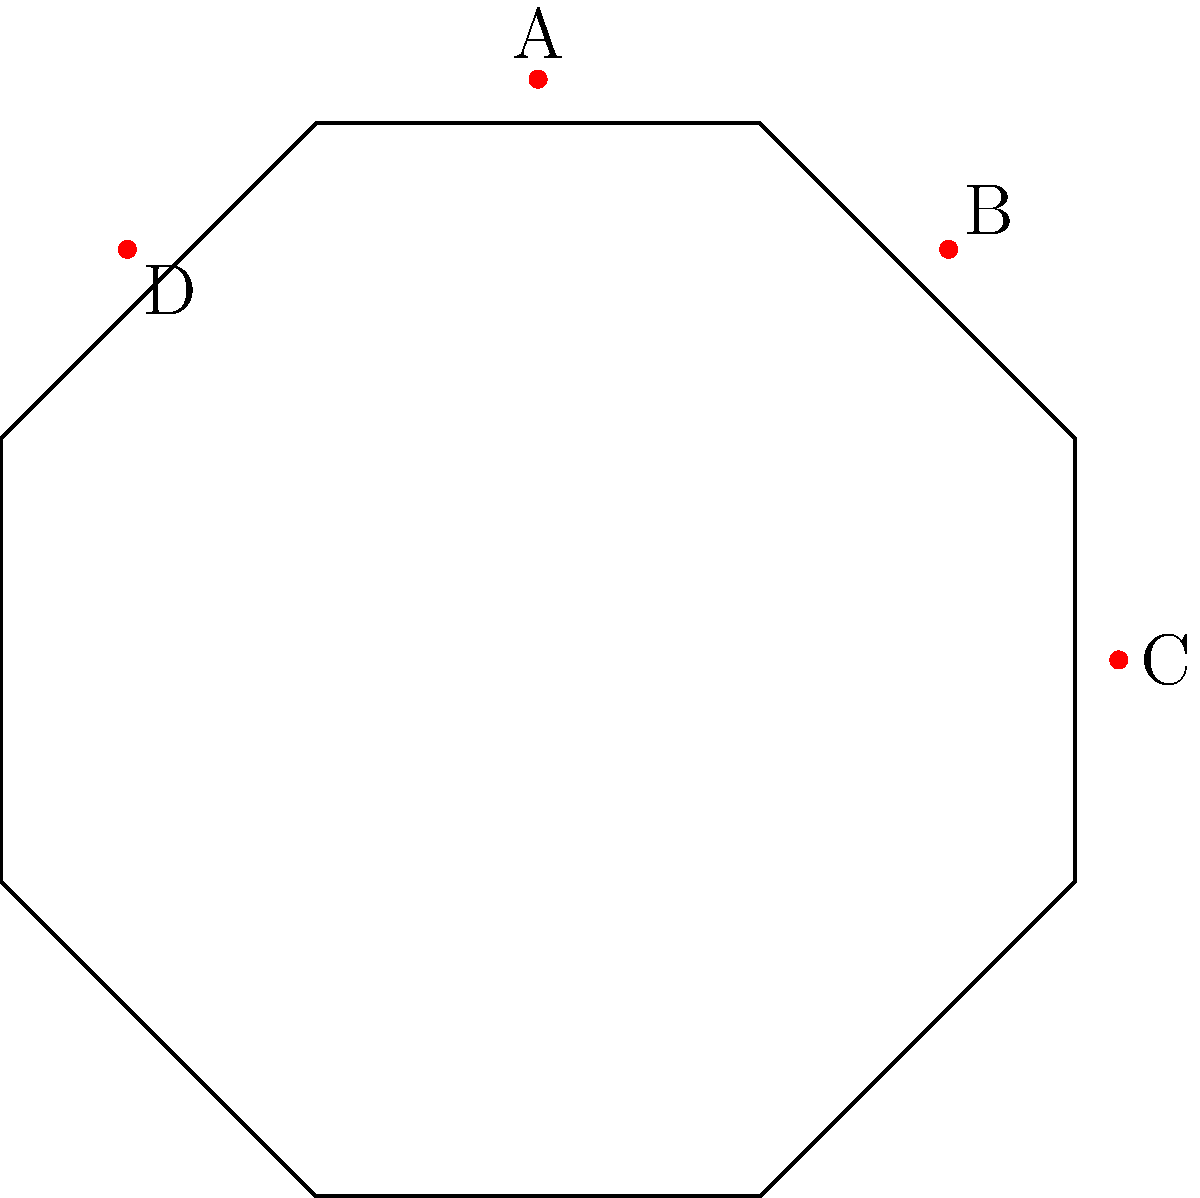As the head of a historical society, you're reviewing a tour plan for a unique octagonal building. The floor plan is shown above, with four key points marked A, B, C, and D. What is the order of the symmetry group for this floor plan? To determine the order of the symmetry group for this octagonal floor plan, we need to count the number of distinct symmetry operations:

1. Rotational symmetries:
   - Identity (0° rotation)
   - 45° rotation
   - 90° rotation
   - 135° rotation
   - 180° rotation
   - 225° rotation
   - 270° rotation
   - 315° rotation

2. Reflection symmetries:
   - 8 lines of reflection (4 through vertices and 4 through midpoints of sides)

The total number of symmetry operations is the sum of rotational and reflection symmetries:

$$ \text{Order} = \text{Rotations} + \text{Reflections} = 8 + 8 = 16 $$

Therefore, the order of the symmetry group for this octagonal floor plan is 16.

This symmetry group is known as the dihedral group $D_8$, where the subscript 8 refers to the number of sides in the polygon.
Answer: 16 